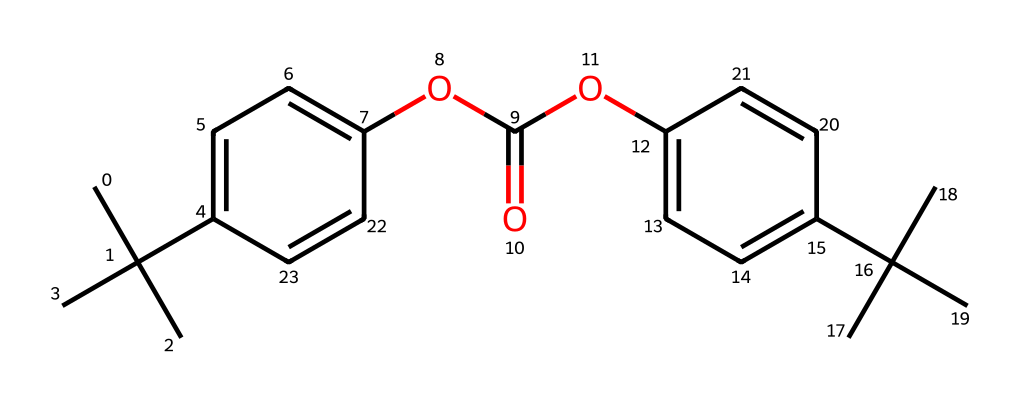how many carbon atoms are in the structure? By examining the SMILES representation, we can count the instances of "C" which indicate carbon atoms. Each occurrence signifies a carbon atom, and considering the embedded branches, we can sum them to find a total. In this case, there are 20 carbon atoms present.
Answer: 20 what functional groups are present in this molecule? In the provided SMILES, the "OC(=O)" indicates the presence of an ester functional group. Additionally, "C(=O)" suggests a carbonyl, part of the ester group. These functional groups demonstrate specific chemical properties and reactivity pertinent to polycarbonate.
Answer: ester what type of polymer is represented by this chemical? This chemical represents a polycarbonate, which is a thermoplastic polymer known for its strong, durable properties and transparency, commonly used in protective sports eyewear. The structures and connections, particularly the carbonate linkage of alternating units, confirm this classification.
Answer: polycarbonate how many oxygen atoms are in the molecule? The SMILES representation includes "O" and "OC," indicating the presence of oxygen atoms. By counting all occurrences of "O" throughout the chemical structure, we find there are 4 oxygen atoms in total.
Answer: 4 what is the main property that makes polycarbonate suitable for protective sports eyewear? Polycarbonate is known for its high impact resistance, which is crucial for protective eyewear. The structure shows a dense arrangement and strong polar bonds, further contributing to its ability to withstand significant force without breaking.
Answer: impact resistance which segment of the molecule gives it its rigidity? The presence of the carbonate moiety (-O-C=O-) in the backbone of this polymer contributes significantly to its rigidity. This segment is responsible for stabilizing the polymer chains and preventing excessive flexibility, making the material suitable for eyewear.
Answer: carbonate moiety 